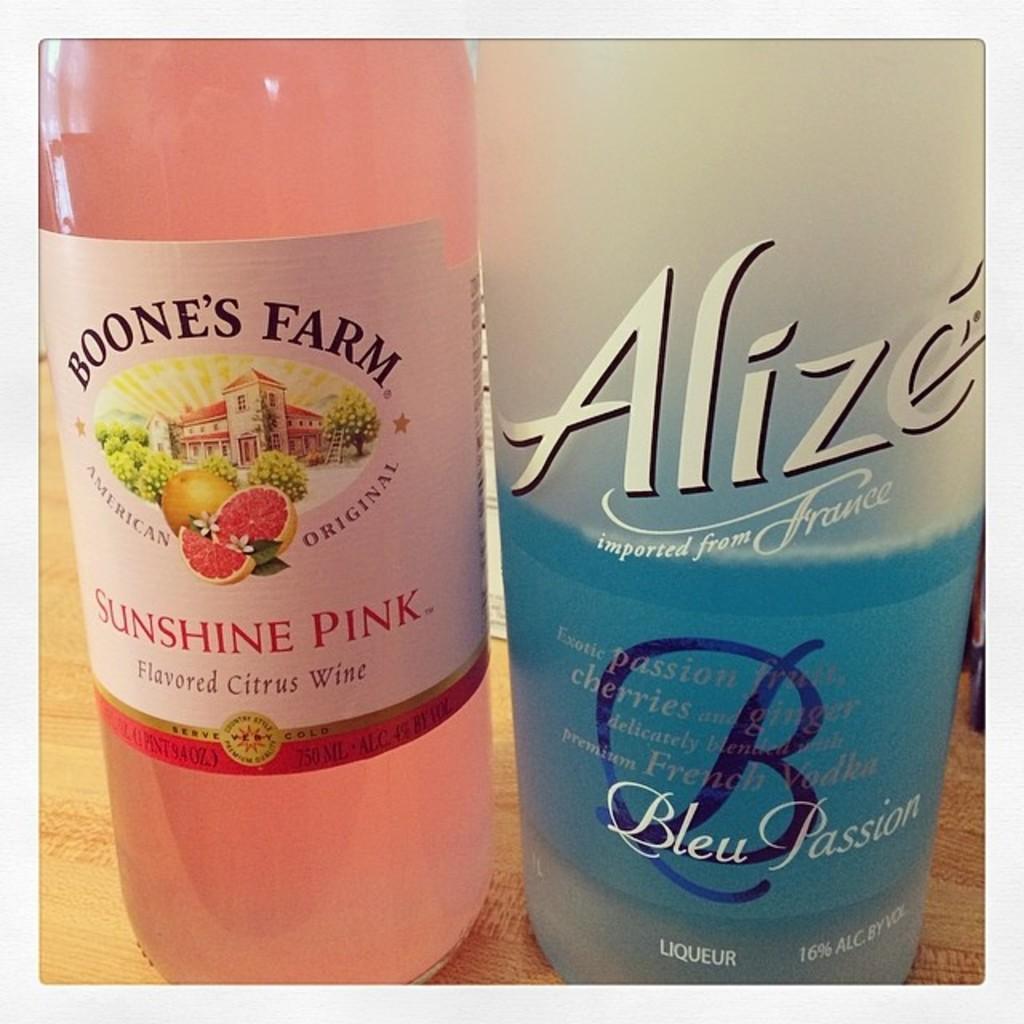In one or two sentences, can you explain what this image depicts? In this image I see 2 bottles. 